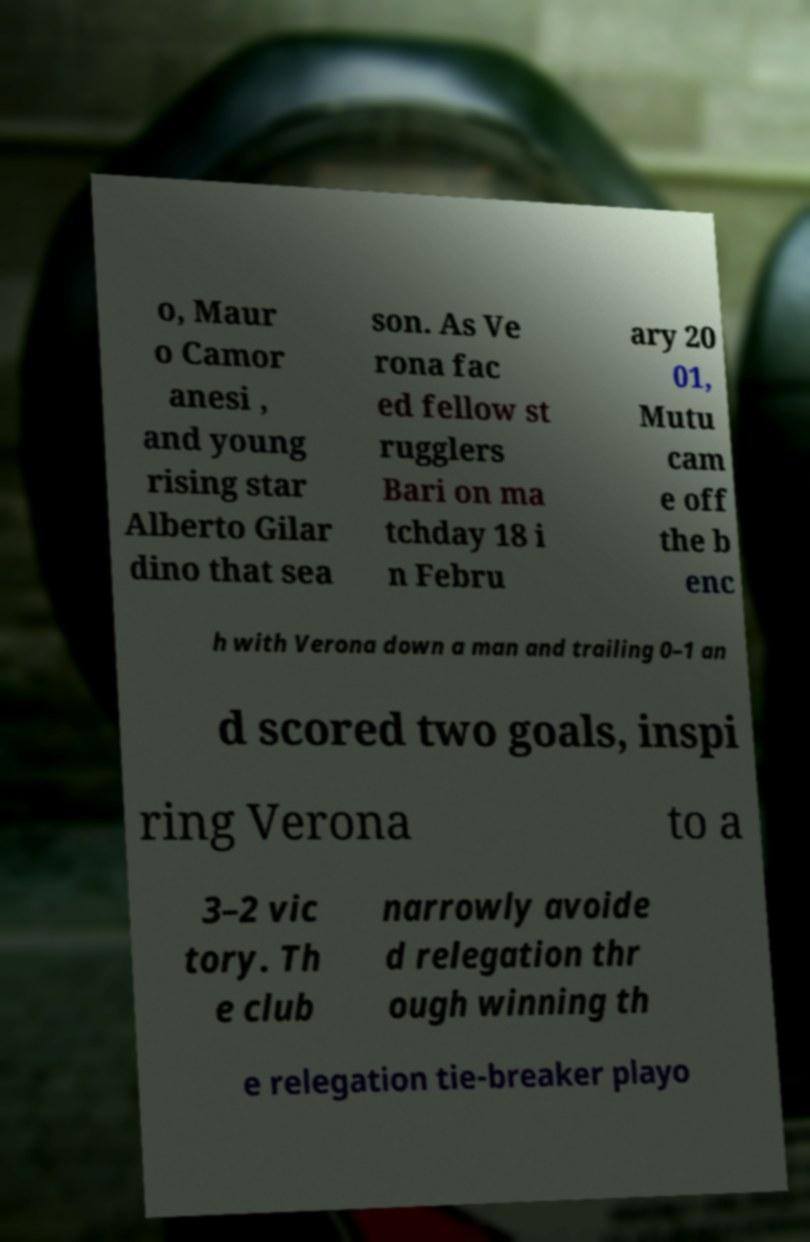There's text embedded in this image that I need extracted. Can you transcribe it verbatim? o, Maur o Camor anesi , and young rising star Alberto Gilar dino that sea son. As Ve rona fac ed fellow st rugglers Bari on ma tchday 18 i n Febru ary 20 01, Mutu cam e off the b enc h with Verona down a man and trailing 0–1 an d scored two goals, inspi ring Verona to a 3–2 vic tory. Th e club narrowly avoide d relegation thr ough winning th e relegation tie-breaker playo 